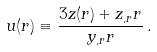Convert formula to latex. <formula><loc_0><loc_0><loc_500><loc_500>u ( r ) \equiv \frac { 3 z ( r ) + z _ { , r } r } { y _ { , r } r } \, .</formula> 